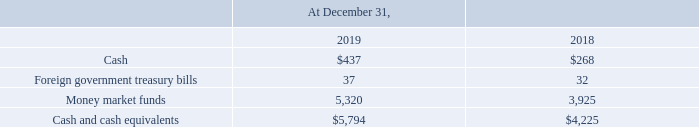4. Cash and Cash Equivalents
The following table summarizes the components of our cash and cash equivalents (amounts in millions):
What was the cash amount in 2019?
Answer scale should be: million. 437. What was the foreign government treasure bills amount in 2019?
Answer scale should be: million. 37. What was the amount of cash and cash equivalents in 2018?
Answer scale should be: million. 4,225. What was the change in cash between 2018 and 2019?
Answer scale should be: million. 437-268
Answer: 169. What was the change in money market funds between 2018 and 2019?
Answer scale should be: million. (5,320-3,925)
Answer: 1395. What was the percentage change in cash and cash equivalents between 2018 and 2019?
Answer scale should be: percent. ($5,794-$4,225)/$4,225
Answer: 37.14. 